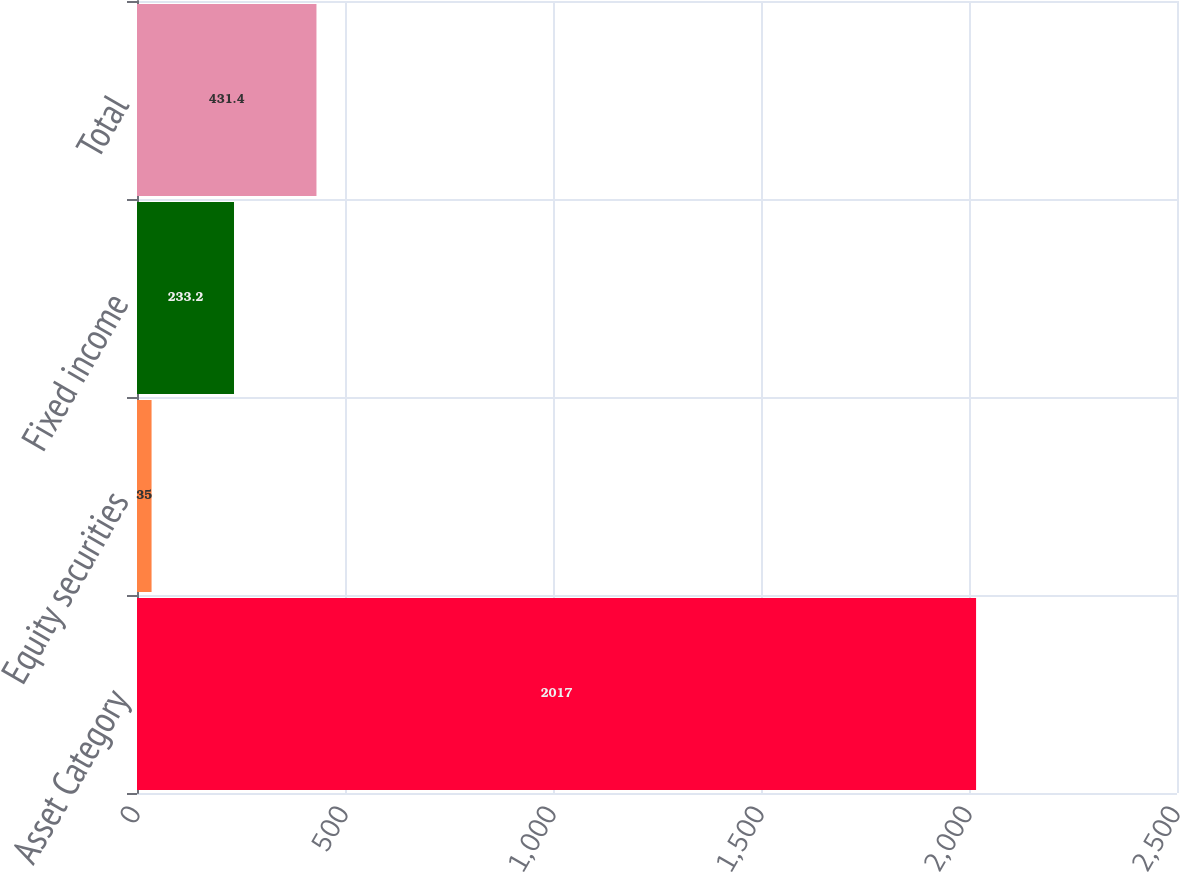Convert chart to OTSL. <chart><loc_0><loc_0><loc_500><loc_500><bar_chart><fcel>Asset Category<fcel>Equity securities<fcel>Fixed income<fcel>Total<nl><fcel>2017<fcel>35<fcel>233.2<fcel>431.4<nl></chart> 